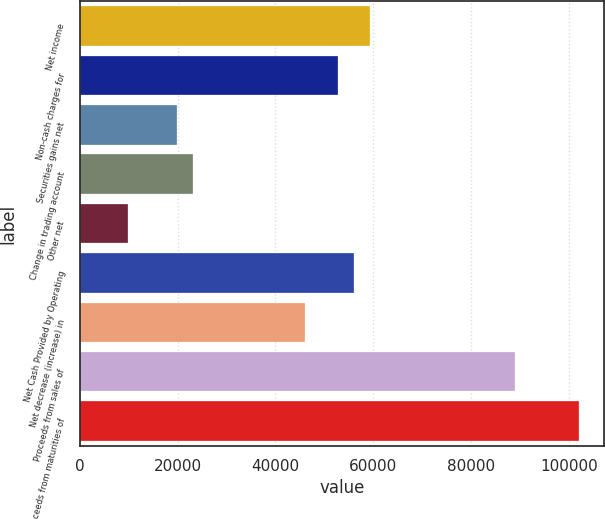Convert chart to OTSL. <chart><loc_0><loc_0><loc_500><loc_500><bar_chart><fcel>Net income<fcel>Non-cash charges for<fcel>Securities gains net<fcel>Change in trading account<fcel>Other net<fcel>Net Cash Provided by Operating<fcel>Net decrease (increase) in<fcel>Proceeds from sales of<fcel>Proceeds from maturities of<nl><fcel>59315.6<fcel>52725.2<fcel>19773.2<fcel>23068.4<fcel>9887.6<fcel>56020.4<fcel>46134.8<fcel>88972.4<fcel>102153<nl></chart> 